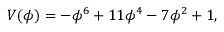Convert formula to latex. <formula><loc_0><loc_0><loc_500><loc_500>V ( \phi ) = - \phi ^ { 6 } + 1 1 \phi ^ { 4 } - 7 \phi ^ { 2 } + 1 ,</formula> 